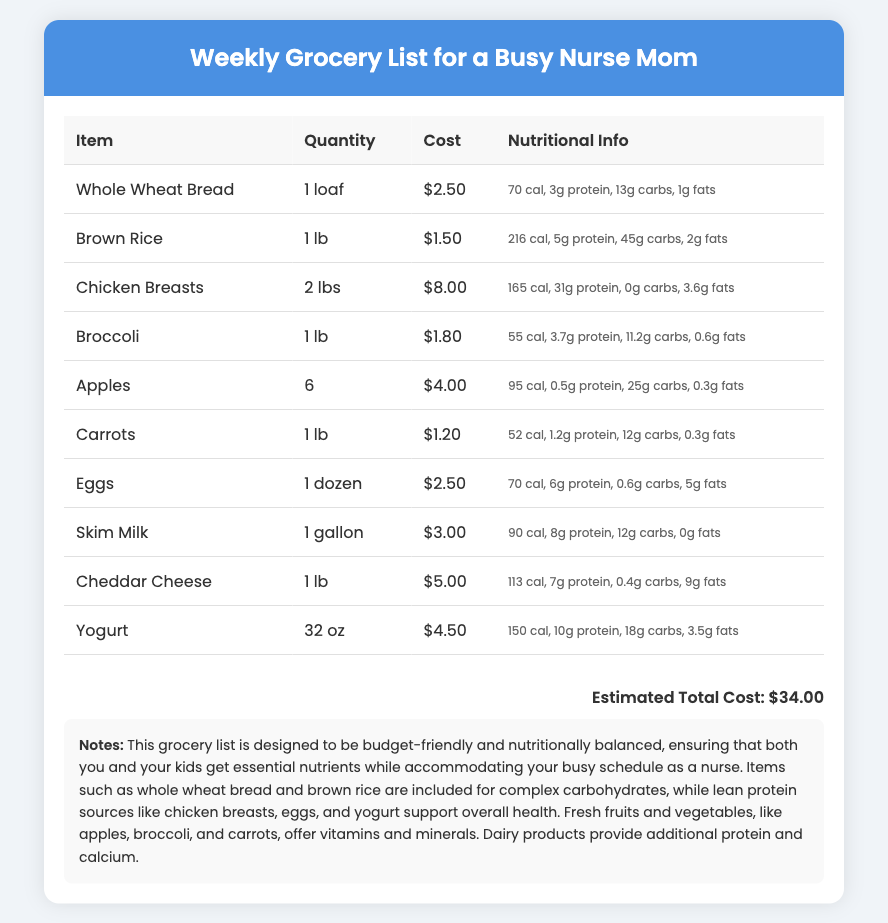What is the estimated total cost? The estimated total cost is a sum of all the grocery items listed in the document, which amounts to $34.00.
Answer: $34.00 How many apples are included in the list? The quantity of apples is specified in the grocery list as 6.
Answer: 6 What is the quantity of chicken breasts? The grocery list states that chicken breasts are provided in a quantity of 2 lbs.
Answer: 2 lbs What is the nutritional information for broccoli? The nutritional information for broccoli includes calories, protein, carbs, and fats, summarized in the table as 55 cal, 3.7g protein, 11.2g carbs, and 0.6g fats.
Answer: 55 cal, 3.7g protein, 11.2g carbs, 0.6g fats Which item has the highest cost? The item on the list with the highest cost is cheddar cheese, which is priced at $5.00.
Answer: Cheddar Cheese How many grams of protein are in eggs? The document indicates that eggs contain 6 grams of protein per serving, as listed in the nutritional information.
Answer: 6g Which vegetables are included in the grocery list? The vegetables included in the grocery list are broccoli and carrots.
Answer: Broccoli, Carrots What does the note section describe? The notes section describes the purpose of the grocery list, which is to be budget-friendly and nutritionally balanced for a busy nurse mom and her kids.
Answer: Budget-friendly and nutritionally balanced What type of bread is listed? The document specifies that the type of bread included in the grocery list is whole wheat bread.
Answer: Whole Wheat Bread 